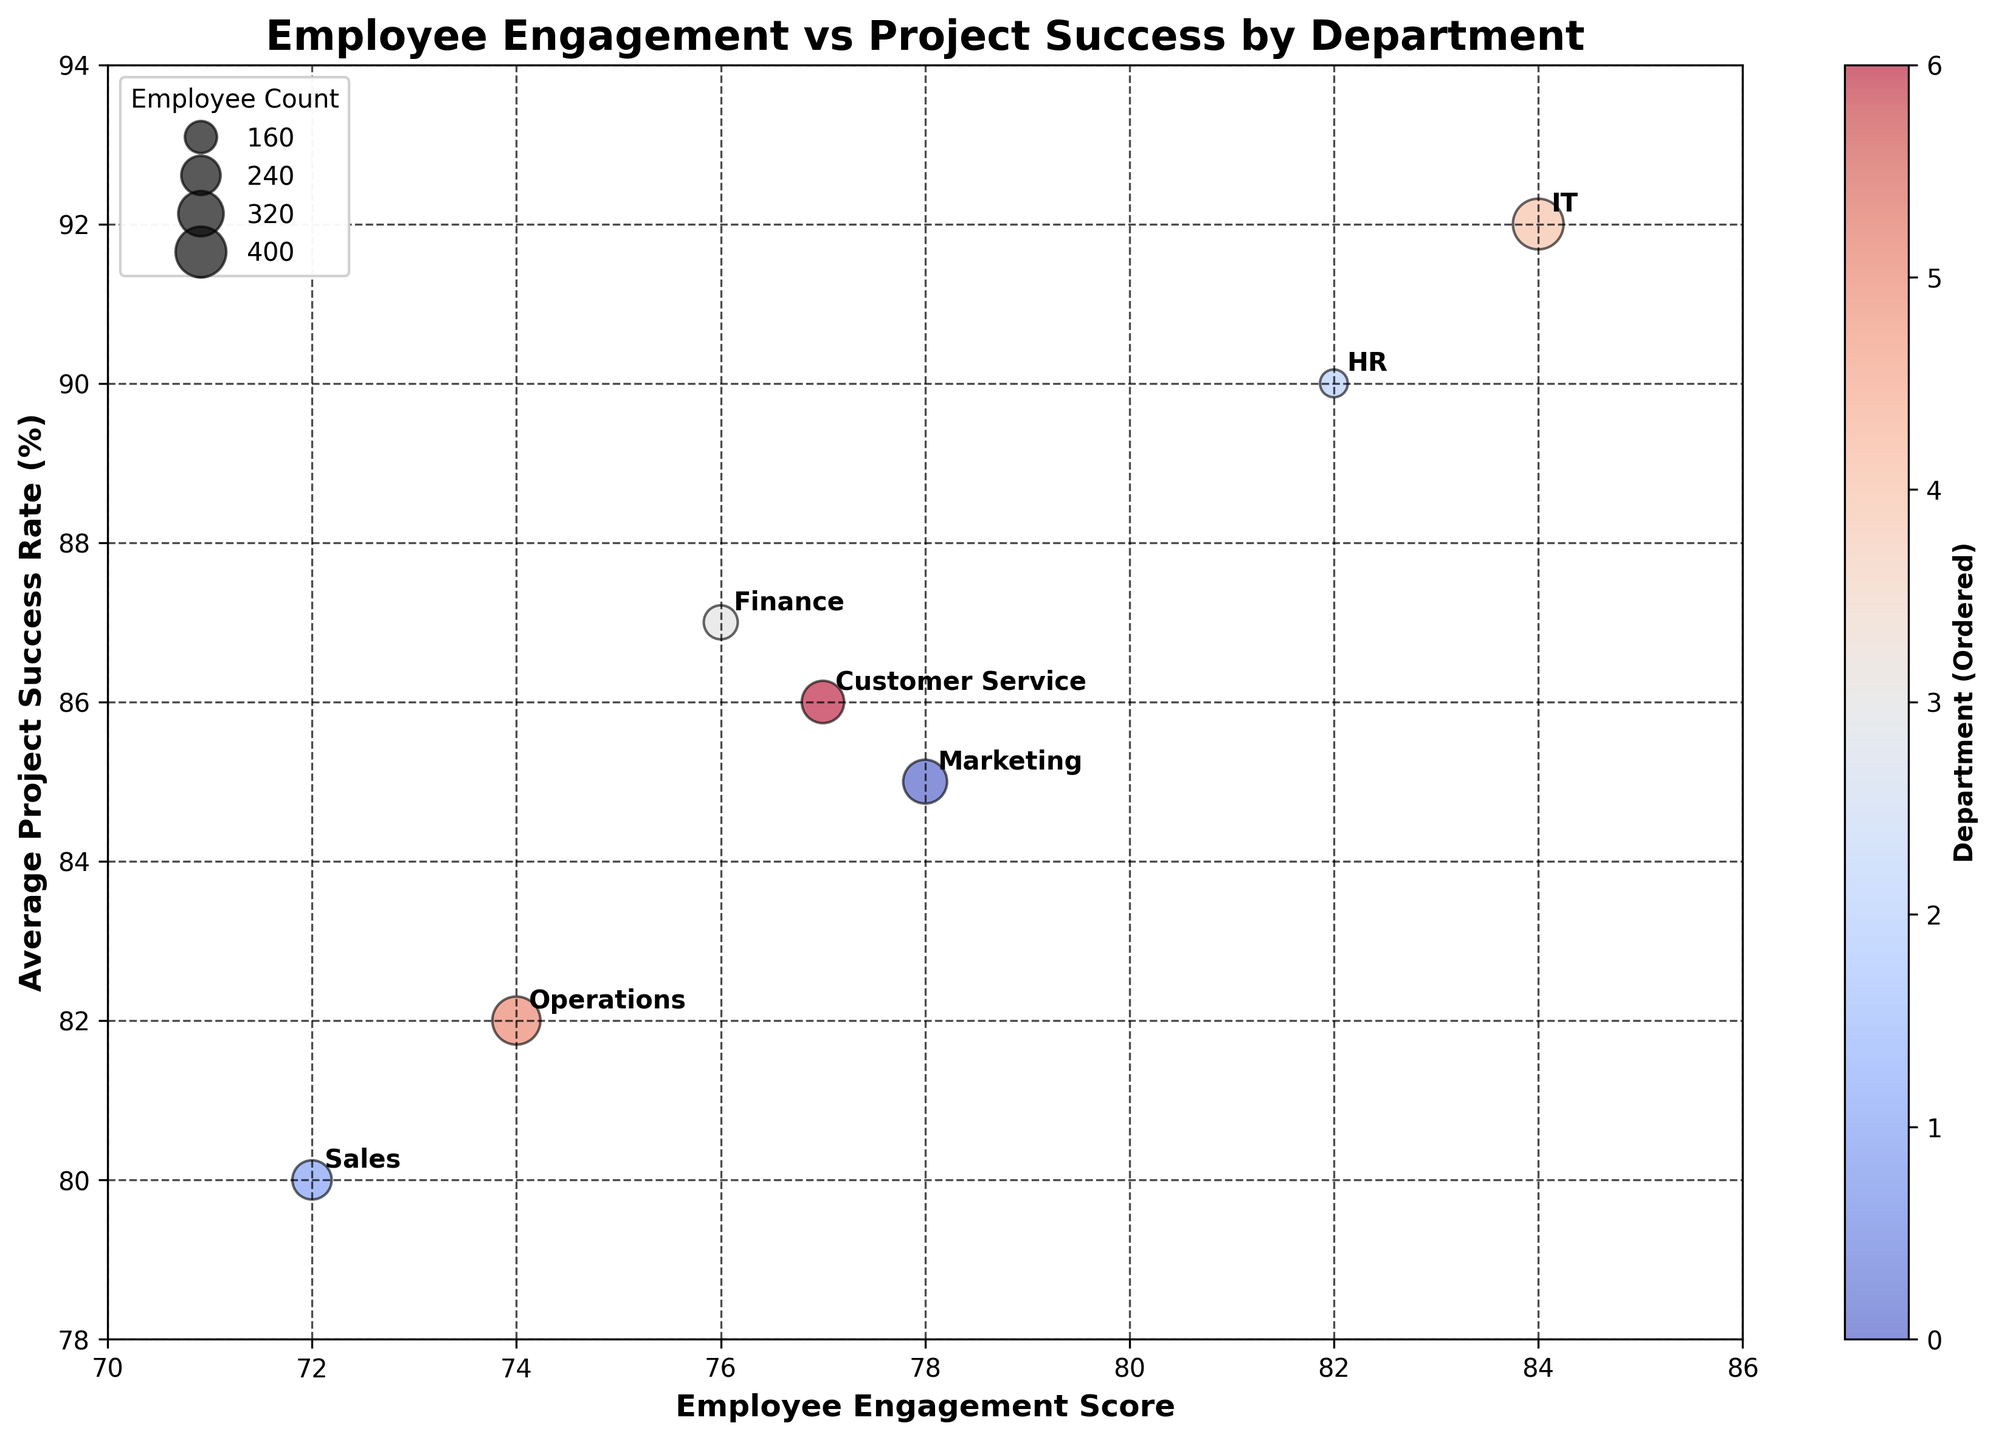What's the highest Employee Engagement Score among the departments? By looking at the x-axis, the highest x-value will tell us the highest Employee Engagement Score. The IT department has the highest score.
Answer: 84 Which department has the lowest Project Success Rate? By observing the y-axis, the Sales department has the lowest y-value, indicating it has the lowest Project Success Rate.
Answer: Sales What's the average Employee Engagement Score of the departments? Sum all the Employee Engagement Scores (78 + 72 + 82 + 76 + 84 + 74 + 77) and divide by the number of departments (7). The calculation is (543/7), which equals approximately 77.57.
Answer: 77.57 Which department has the largest employee count, and how can you tell? The size of the bubble represents the employee count, with the largest bubble corresponding to the IT department.
Answer: IT Are there any departments with both high Employee Engagement Scores and high Project Success Rates? Departments with high values on both axes include IT (84, 92) and HR (82, 90).
Answer: IT, HR Which department shows a balanced approach with neither the highest nor the lowest engagement or project success rate? Departments falling near the middle of both axes include Marketing (78, 85) and Customer Service (77, 86).
Answer: Marketing, Customer Service How does the Engagement Score of Sales compare with that of Operations? The x-value for Sales (72) is lower than for Operations (74), showing Sales has a lower Engagement Score.
Answer: Sales is lower How many departments have an Employee Engagement Score above 75? Counting the bubbles with values on the x-axis above 75 shows 5 departments: Marketing, HR, Finance, IT, and Customer Service.
Answer: 5 What's the range of Project Success Rates displayed in the figure? The y-axis shows the minimum value of Project Success Rate is 80 (Sales), and the maximum is 92 (IT), so the range is 92 - 80 which equals 12.
Answer: 12 Which department has close coordination between its Employee Engagement Score and Average Project Success Rate, judging both values are close to each other? Since Employee Engagement Scores and Project Success Rates can have different scales, we look for departments where the two values are in a similar range, such as HR (82, 90).
Answer: HR 